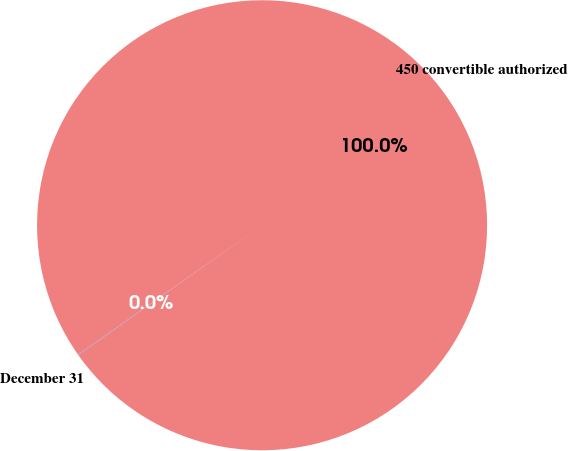Convert chart to OTSL. <chart><loc_0><loc_0><loc_500><loc_500><pie_chart><fcel>December 31<fcel>450 convertible authorized<nl><fcel>0.04%<fcel>99.96%<nl></chart> 